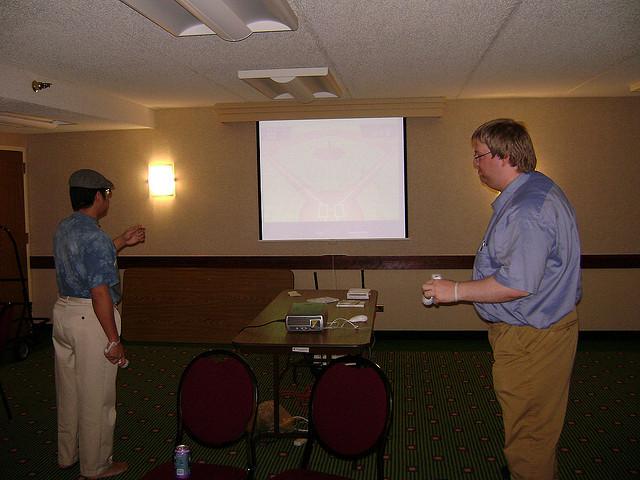What kind of room is this?
Short answer required. Conference. How many people are in the room?
Concise answer only. 2. Is the man wearing a jacket?
Short answer required. No. Is anyone wearing a watch?
Write a very short answer. No. What is the screen for?
Answer briefly. Projection. Are the 2 men in a house?
Write a very short answer. No. Do both men have glasses?
Keep it brief. Yes. What are they holding?
Short answer required. Remotes. Is there a bench in this photo?
Keep it brief. No. What is on the blue shirt?
Answer briefly. Nothing. Where are these people standing?
Quick response, please. Conference room. How many people are standing?
Give a very brief answer. 2. 